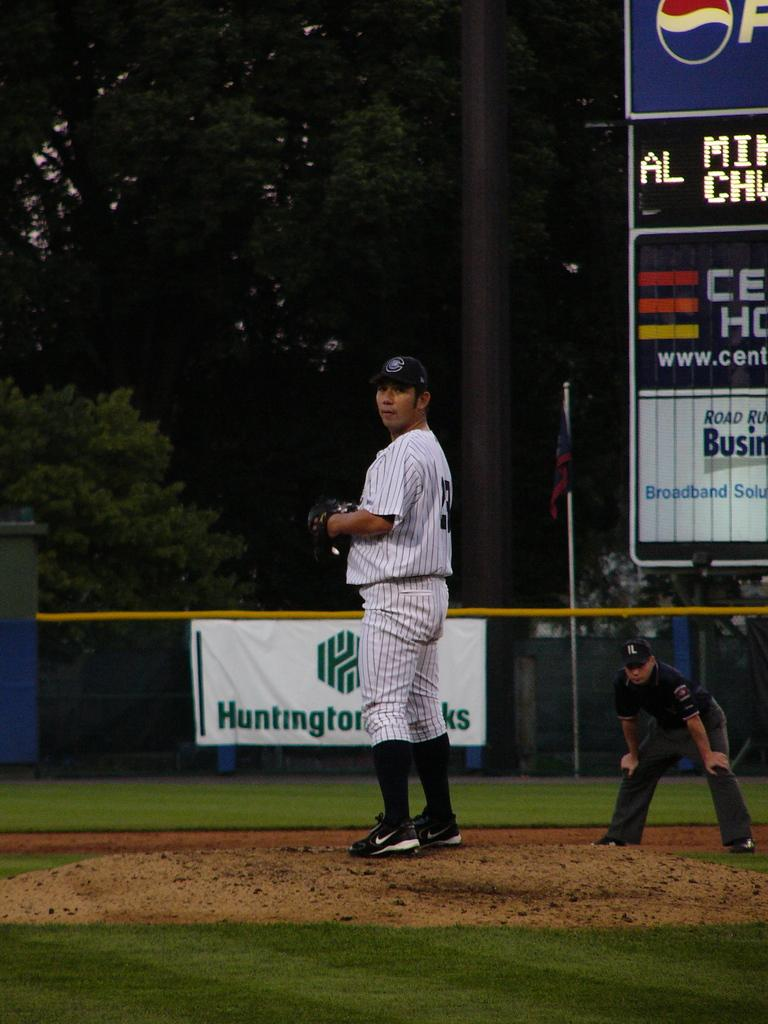<image>
Relay a brief, clear account of the picture shown. Huntington banks has a banner along the fence line to advertise during the game. 